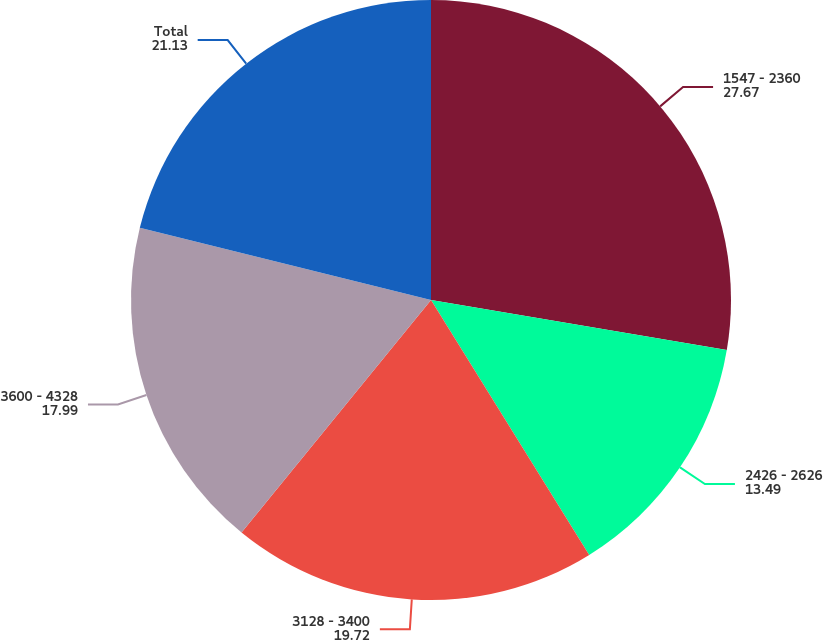Convert chart. <chart><loc_0><loc_0><loc_500><loc_500><pie_chart><fcel>1547 - 2360<fcel>2426 - 2626<fcel>3128 - 3400<fcel>3600 - 4328<fcel>Total<nl><fcel>27.67%<fcel>13.49%<fcel>19.72%<fcel>17.99%<fcel>21.13%<nl></chart> 